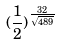Convert formula to latex. <formula><loc_0><loc_0><loc_500><loc_500>( \frac { 1 } { 2 } ) ^ { \frac { 3 2 } { \sqrt { 4 8 9 } } }</formula> 